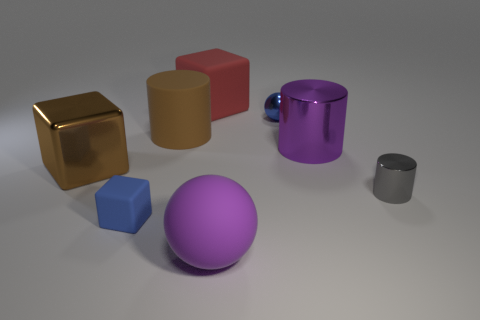There is a big purple object that is made of the same material as the tiny gray object; what is its shape? cylinder 